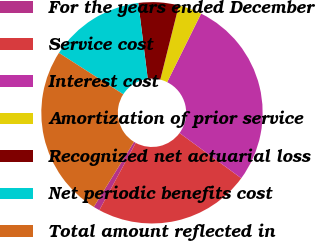Convert chart to OTSL. <chart><loc_0><loc_0><loc_500><loc_500><pie_chart><fcel>For the years ended December<fcel>Service cost<fcel>Interest cost<fcel>Amortization of prior service<fcel>Recognized net actuarial loss<fcel>Net periodic benefits cost<fcel>Total amount reflected in<nl><fcel>0.93%<fcel>22.82%<fcel>27.76%<fcel>3.41%<fcel>5.88%<fcel>13.92%<fcel>25.29%<nl></chart> 